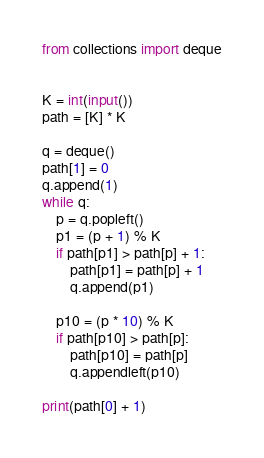<code> <loc_0><loc_0><loc_500><loc_500><_Python_>from collections import deque


K = int(input())
path = [K] * K

q = deque()
path[1] = 0
q.append(1)
while q:
    p = q.popleft()
    p1 = (p + 1) % K
    if path[p1] > path[p] + 1:
        path[p1] = path[p] + 1
        q.append(p1)
    
    p10 = (p * 10) % K
    if path[p10] > path[p]:
        path[p10] = path[p]
        q.appendleft(p10)

print(path[0] + 1)
</code> 